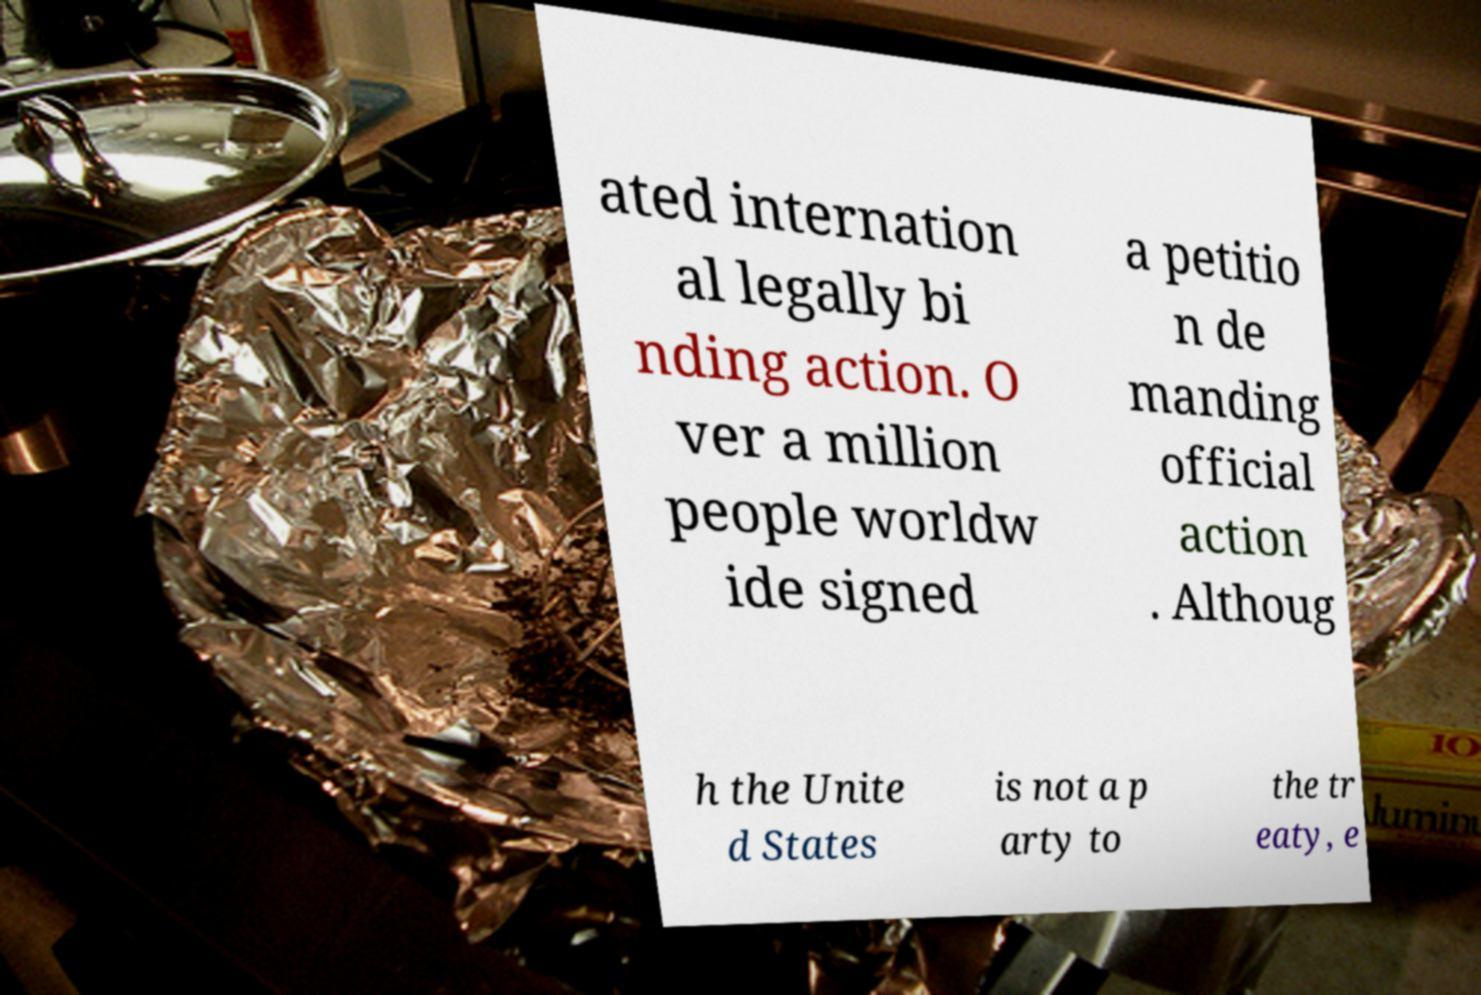I need the written content from this picture converted into text. Can you do that? ated internation al legally bi nding action. O ver a million people worldw ide signed a petitio n de manding official action . Althoug h the Unite d States is not a p arty to the tr eaty, e 